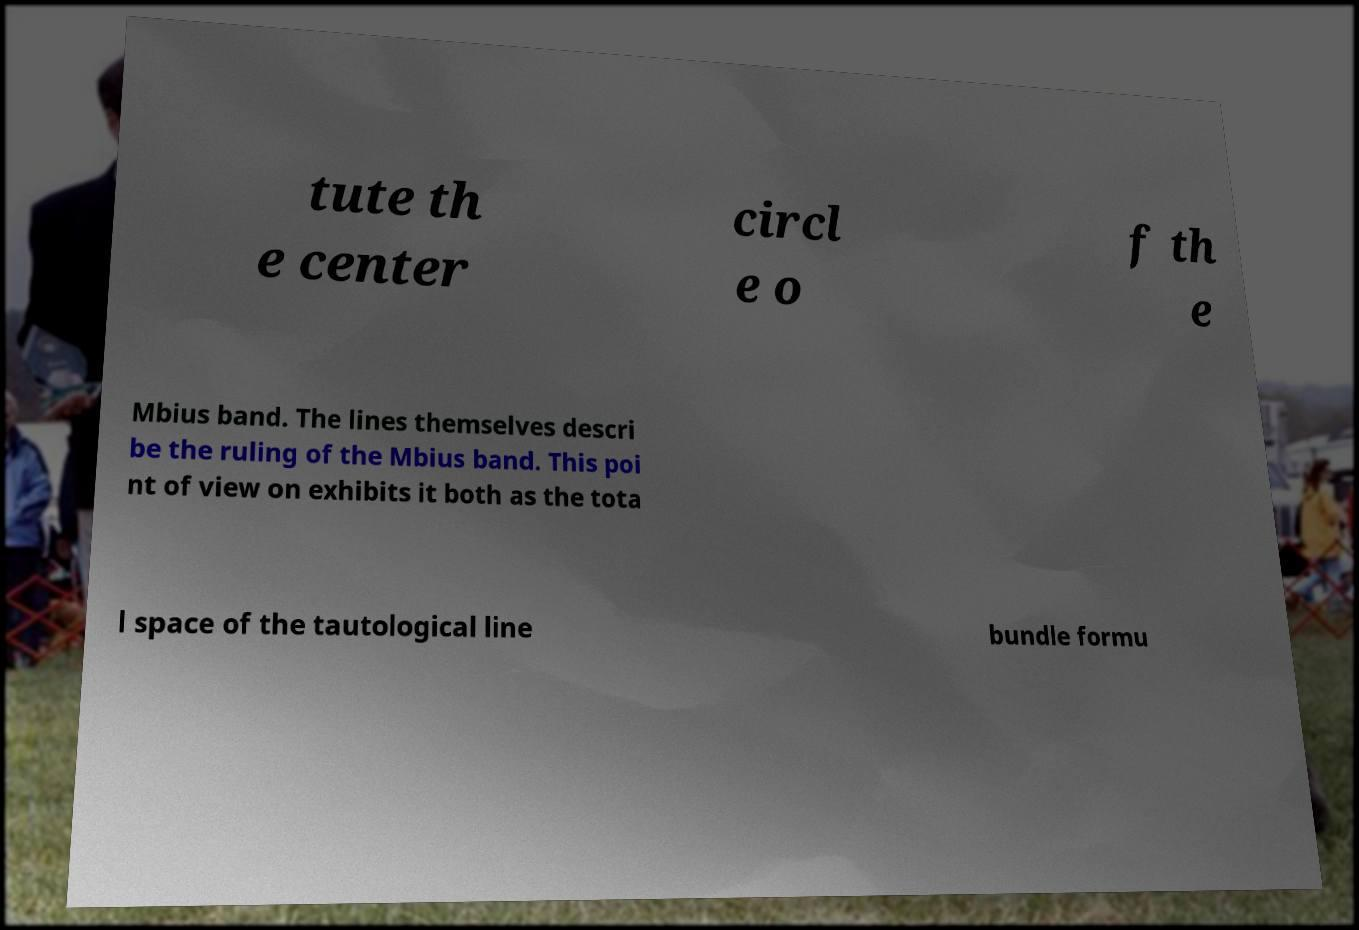There's text embedded in this image that I need extracted. Can you transcribe it verbatim? tute th e center circl e o f th e Mbius band. The lines themselves descri be the ruling of the Mbius band. This poi nt of view on exhibits it both as the tota l space of the tautological line bundle formu 